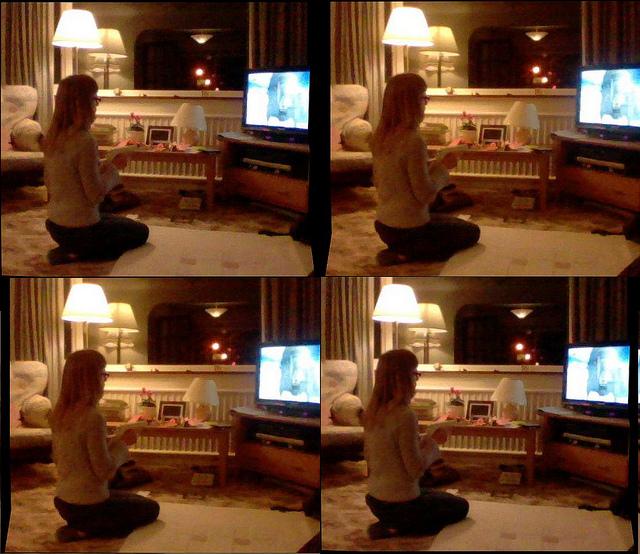How many sources of light are seen here?
Give a very brief answer. 3. What is the girl sitting on?
Short answer required. Floor. Is the girl trying to find an interesting TV program?
Concise answer only. Yes. 